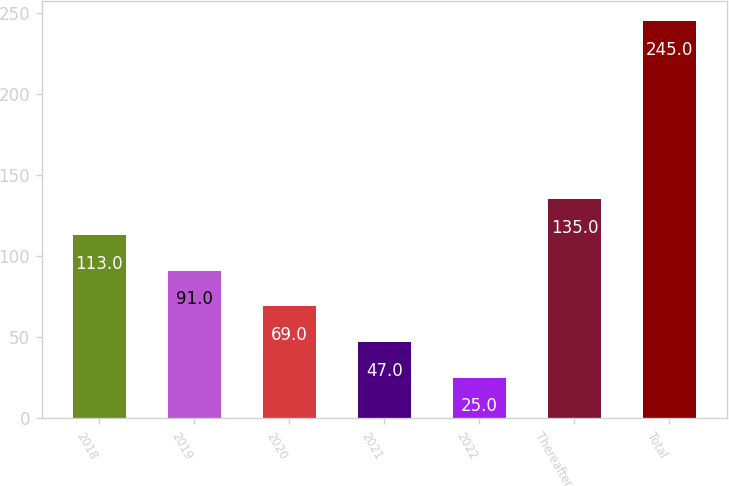Convert chart. <chart><loc_0><loc_0><loc_500><loc_500><bar_chart><fcel>2018<fcel>2019<fcel>2020<fcel>2021<fcel>2022<fcel>Thereafter<fcel>Total<nl><fcel>113<fcel>91<fcel>69<fcel>47<fcel>25<fcel>135<fcel>245<nl></chart> 